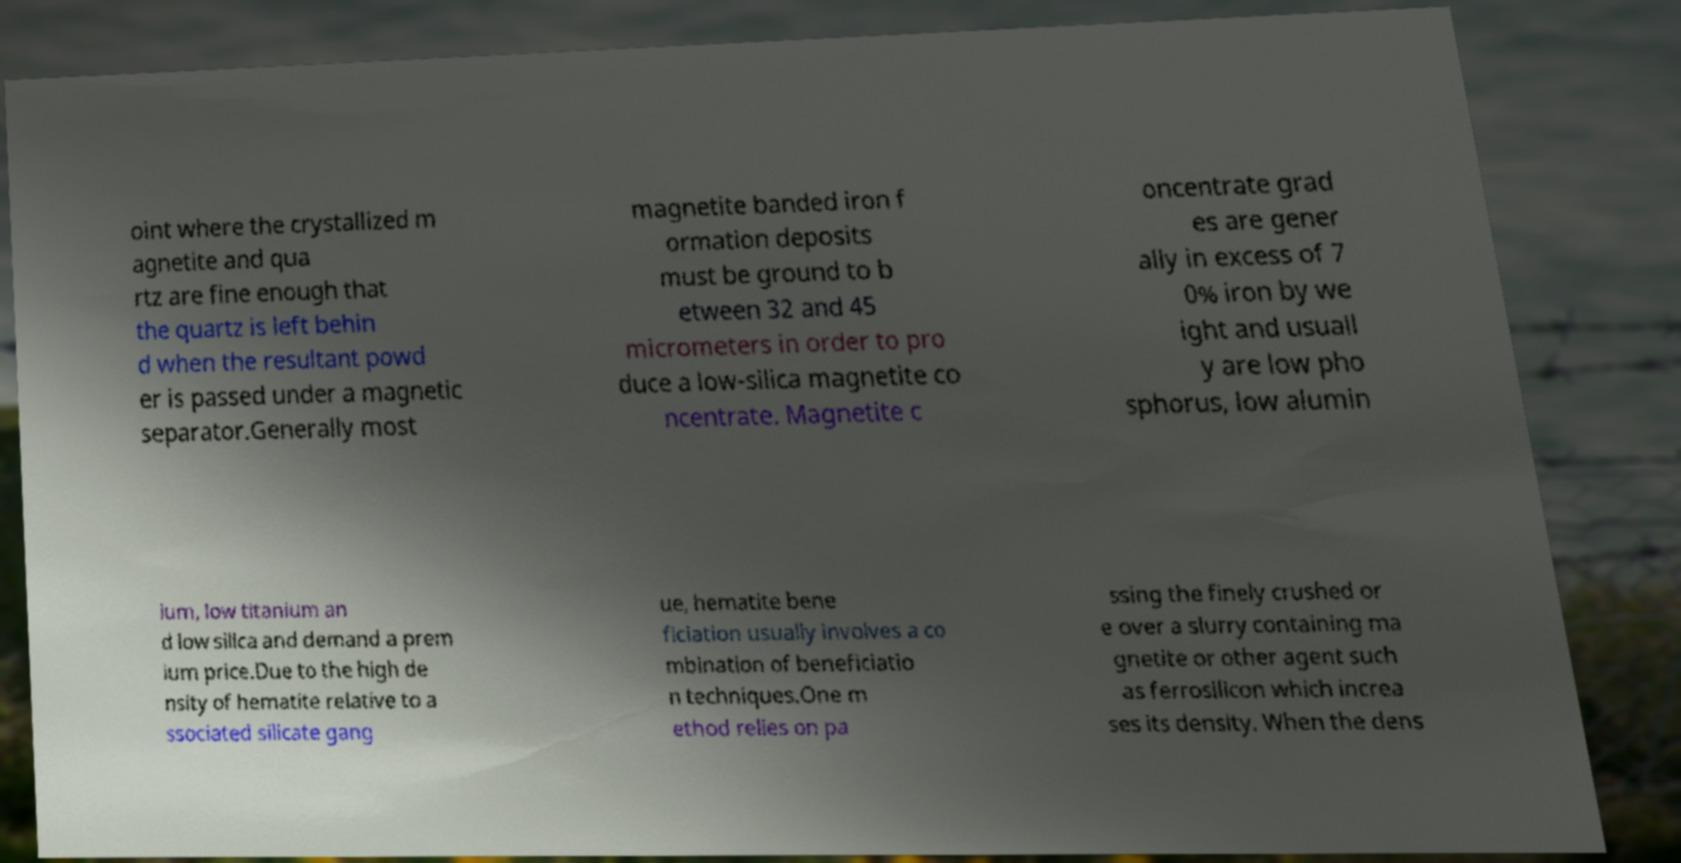There's text embedded in this image that I need extracted. Can you transcribe it verbatim? oint where the crystallized m agnetite and qua rtz are fine enough that the quartz is left behin d when the resultant powd er is passed under a magnetic separator.Generally most magnetite banded iron f ormation deposits must be ground to b etween 32 and 45 micrometers in order to pro duce a low-silica magnetite co ncentrate. Magnetite c oncentrate grad es are gener ally in excess of 7 0% iron by we ight and usuall y are low pho sphorus, low alumin ium, low titanium an d low silica and demand a prem ium price.Due to the high de nsity of hematite relative to a ssociated silicate gang ue, hematite bene ficiation usually involves a co mbination of beneficiatio n techniques.One m ethod relies on pa ssing the finely crushed or e over a slurry containing ma gnetite or other agent such as ferrosilicon which increa ses its density. When the dens 